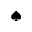<formula> <loc_0><loc_0><loc_500><loc_500>^ { a } d e s u i t</formula> 